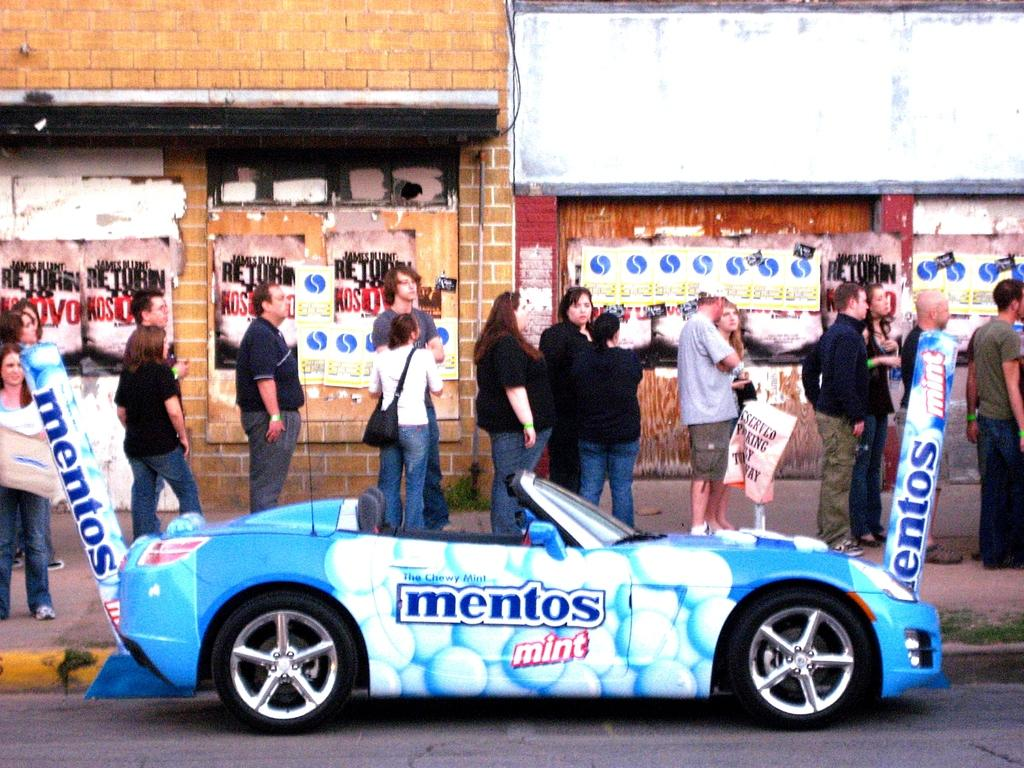What color is the car on the road in the image? The car on the road is blue. What is written on the car? The car has "mentos mint" written on it. What are the people in the image doing? The people are standing in a queue. What can be seen in the background of the image? There are buildings in the background. What type of liquid is being served on a tray in the image? There is no tray or liquid present in the image. Can you describe the bite marks on the car in the image? There are no bite marks on the car in the image; it is a blue car with "mentos mint" written on it. 